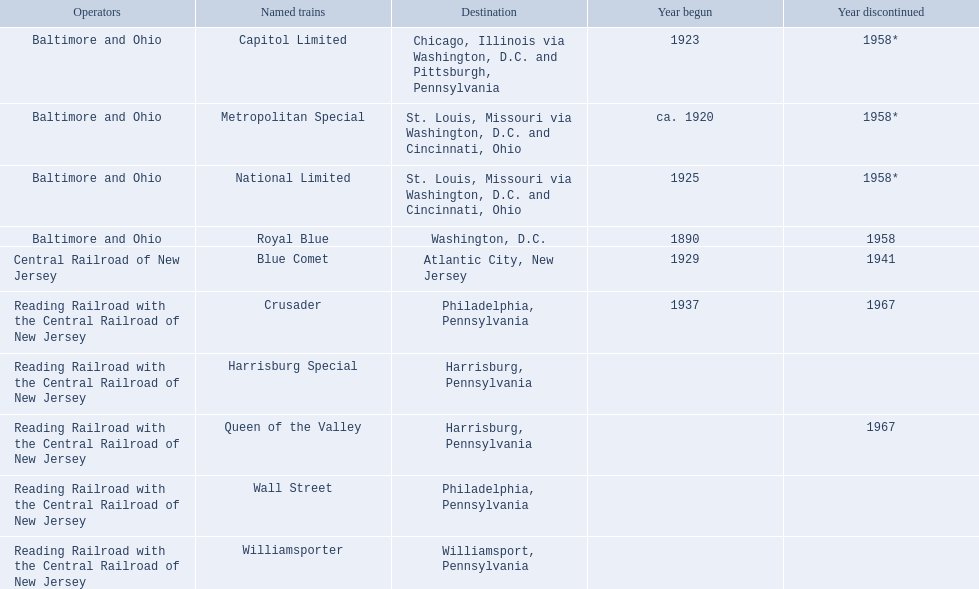What locations are mentioned from the central railroad of new jersey terminal? Chicago, Illinois via Washington, D.C. and Pittsburgh, Pennsylvania, St. Louis, Missouri via Washington, D.C. and Cincinnati, Ohio, St. Louis, Missouri via Washington, D.C. and Cincinnati, Ohio, Washington, D.C., Atlantic City, New Jersey, Philadelphia, Pennsylvania, Harrisburg, Pennsylvania, Harrisburg, Pennsylvania, Philadelphia, Pennsylvania, Williamsport, Pennsylvania. Which of these locations is mentioned first? Chicago, Illinois via Washington, D.C. and Pittsburgh, Pennsylvania. Give me the full table as a dictionary. {'header': ['Operators', 'Named trains', 'Destination', 'Year begun', 'Year discontinued'], 'rows': [['Baltimore and Ohio', 'Capitol Limited', 'Chicago, Illinois via Washington, D.C. and Pittsburgh, Pennsylvania', '1923', '1958*'], ['Baltimore and Ohio', 'Metropolitan Special', 'St. Louis, Missouri via Washington, D.C. and Cincinnati, Ohio', 'ca. 1920', '1958*'], ['Baltimore and Ohio', 'National Limited', 'St. Louis, Missouri via Washington, D.C. and Cincinnati, Ohio', '1925', '1958*'], ['Baltimore and Ohio', 'Royal Blue', 'Washington, D.C.', '1890', '1958'], ['Central Railroad of New Jersey', 'Blue Comet', 'Atlantic City, New Jersey', '1929', '1941'], ['Reading Railroad with the Central Railroad of New Jersey', 'Crusader', 'Philadelphia, Pennsylvania', '1937', '1967'], ['Reading Railroad with the Central Railroad of New Jersey', 'Harrisburg Special', 'Harrisburg, Pennsylvania', '', ''], ['Reading Railroad with the Central Railroad of New Jersey', 'Queen of the Valley', 'Harrisburg, Pennsylvania', '', '1967'], ['Reading Railroad with the Central Railroad of New Jersey', 'Wall Street', 'Philadelphia, Pennsylvania', '', ''], ['Reading Railroad with the Central Railroad of New Jersey', 'Williamsporter', 'Williamsport, Pennsylvania', '', '']]} 